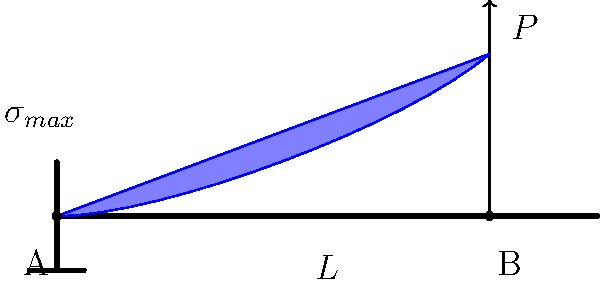A cantilever beam of length $L$ is subjected to a point load $P$ at its free end. If the beam has a rectangular cross-section with width $b$ and height $h$, determine the maximum normal stress $\sigma_{max}$ in the beam. Express your answer in terms of $P$, $L$, $b$, and $h$. To solve this problem, let's follow these steps:

1) First, recall the formula for maximum normal stress in a beam:

   $$\sigma_{max} = \frac{M_{max}y_{max}}{I}$$

   where $M_{max}$ is the maximum bending moment, $y_{max}$ is the distance from the neutral axis to the outermost fiber, and $I$ is the moment of inertia of the cross-section.

2) For a cantilever beam with a point load $P$ at the free end, the maximum bending moment occurs at the fixed end (point A) and is given by:

   $$M_{max} = PL$$

3) For a rectangular cross-section, the moment of inertia $I$ is:

   $$I = \frac{bh^3}{12}$$

4) The distance from the neutral axis to the outermost fiber, $y_{max}$, is half the height of the beam:

   $$y_{max} = \frac{h}{2}$$

5) Now, substitute these values into the stress equation:

   $$\sigma_{max} = \frac{M_{max}y_{max}}{I} = \frac{PL \cdot \frac{h}{2}}{\frac{bh^3}{12}}$$

6) Simplify the equation:

   $$\sigma_{max} = \frac{6PL}{bh^2}$$

This is the final expression for the maximum normal stress in the cantilever beam.
Answer: $\sigma_{max} = \frac{6PL}{bh^2}$ 